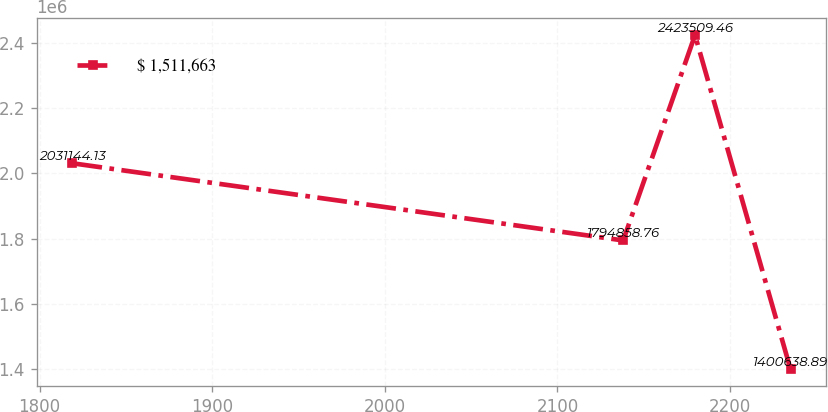Convert chart to OTSL. <chart><loc_0><loc_0><loc_500><loc_500><line_chart><ecel><fcel>$ 1,511,663<nl><fcel>1819.01<fcel>2.03114e+06<nl><fcel>2138.09<fcel>1.79486e+06<nl><fcel>2179.69<fcel>2.42351e+06<nl><fcel>2235.03<fcel>1.40064e+06<nl></chart> 